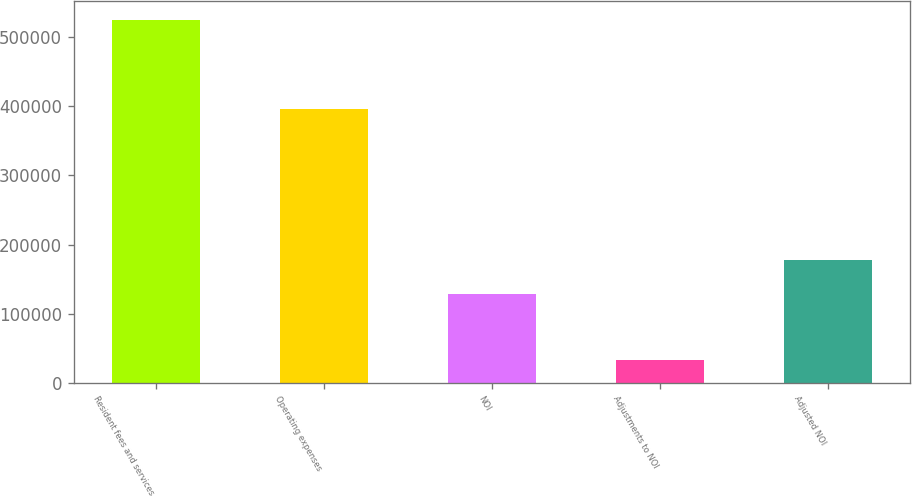<chart> <loc_0><loc_0><loc_500><loc_500><bar_chart><fcel>Resident fees and services<fcel>Operating expenses<fcel>NOI<fcel>Adjustments to NOI<fcel>Adjusted NOI<nl><fcel>525473<fcel>396491<fcel>128982<fcel>33227<fcel>178207<nl></chart> 